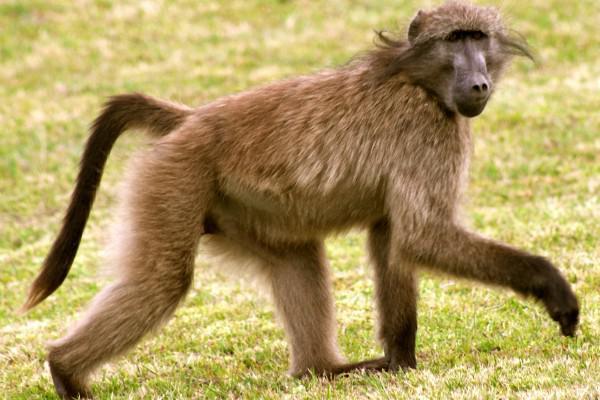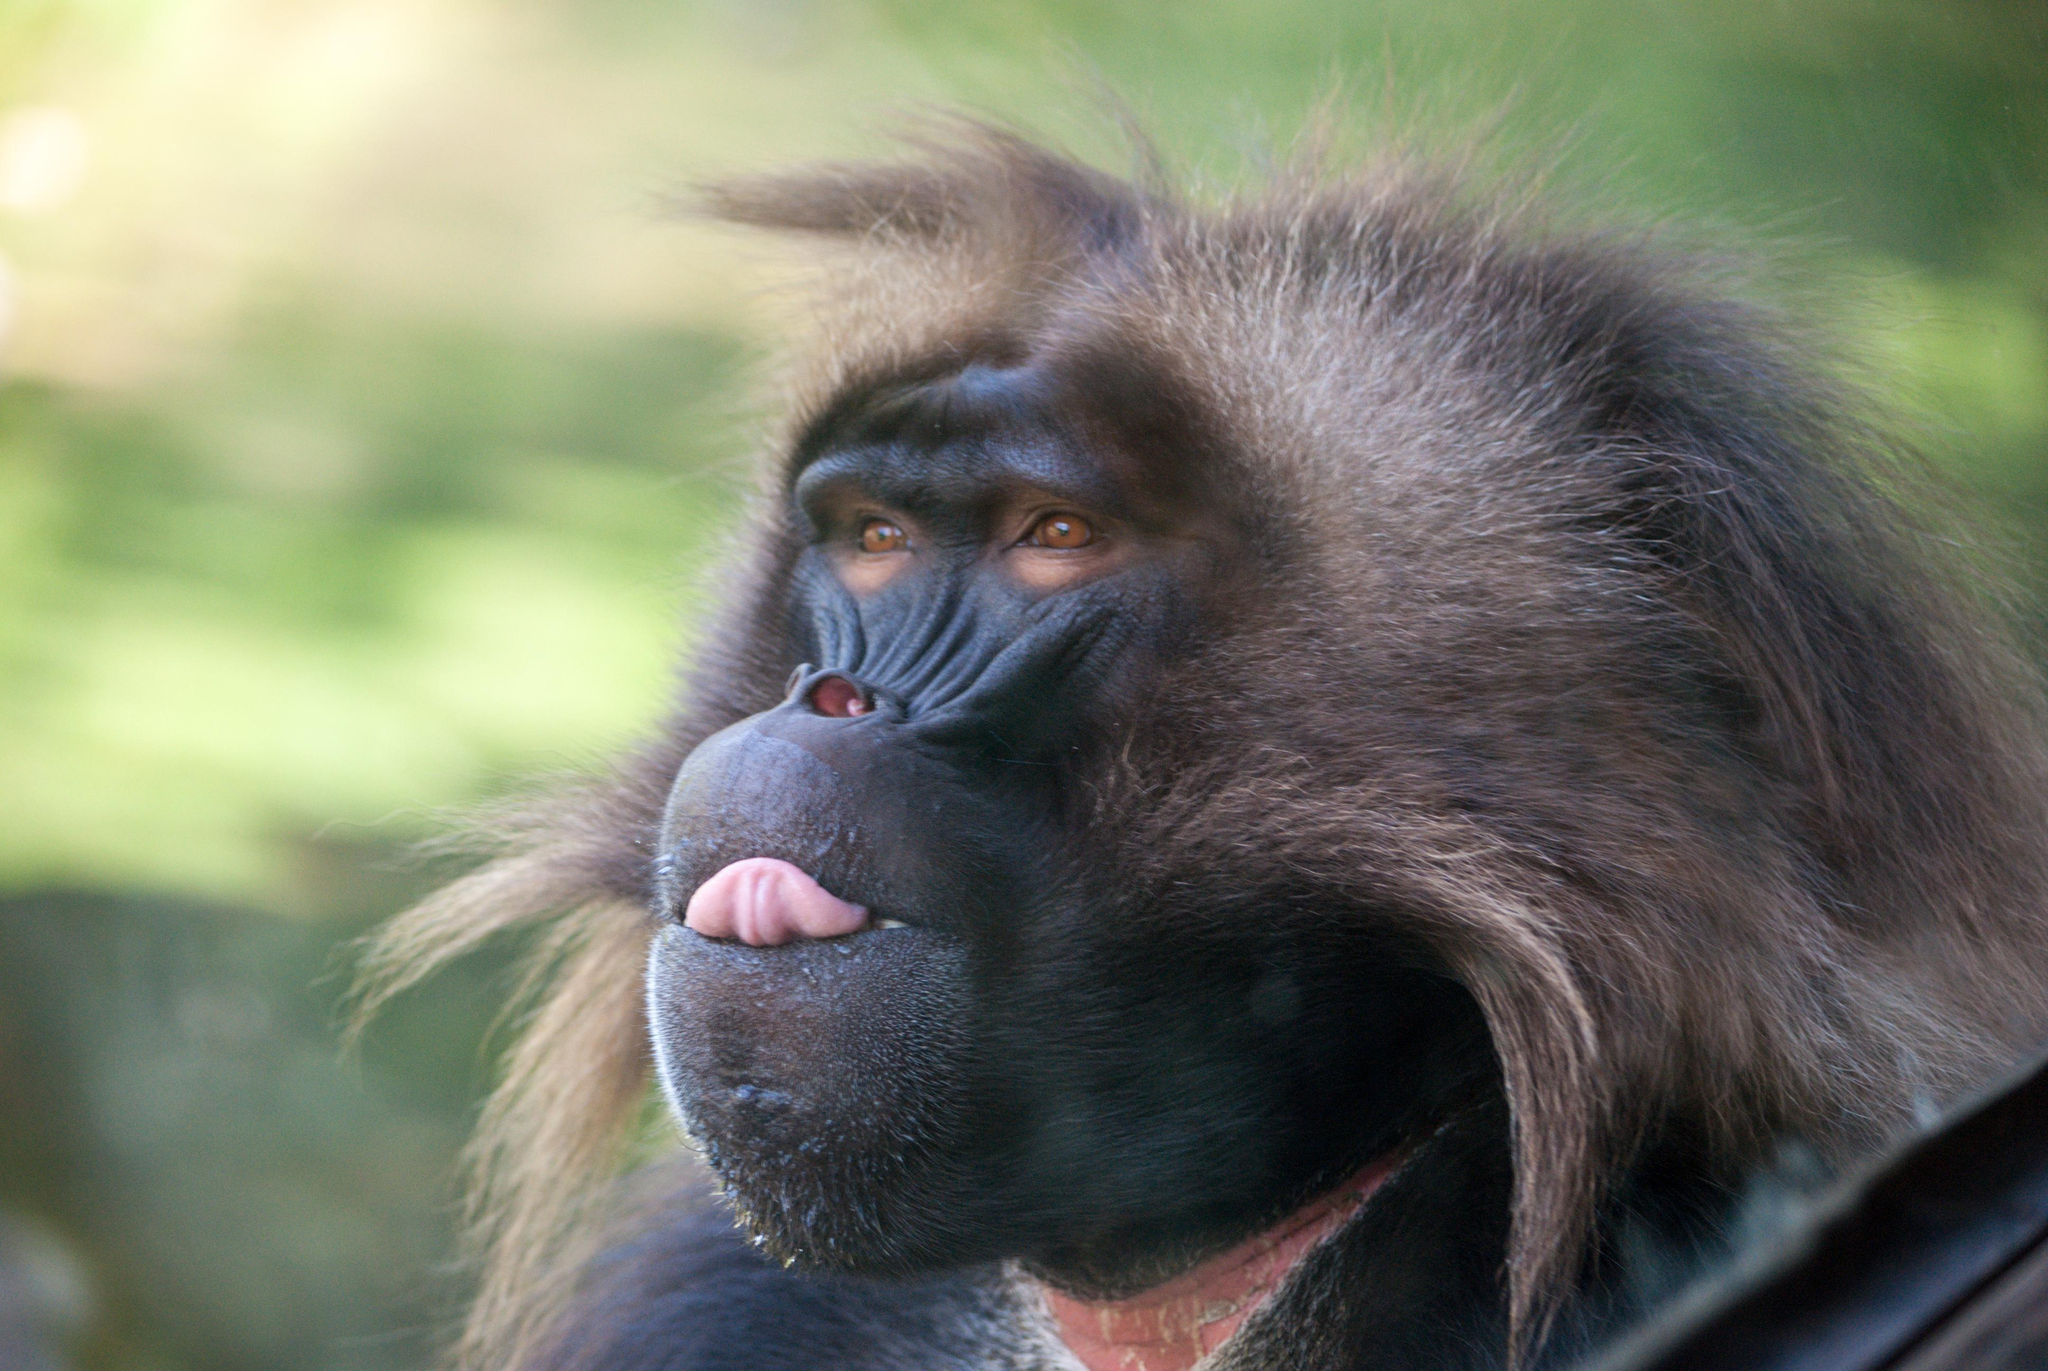The first image is the image on the left, the second image is the image on the right. Evaluate the accuracy of this statement regarding the images: "A baby monkey is with an adult monkey.". Is it true? Answer yes or no. No. 